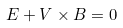Convert formula to latex. <formula><loc_0><loc_0><loc_500><loc_500>E + V \times B = 0</formula> 